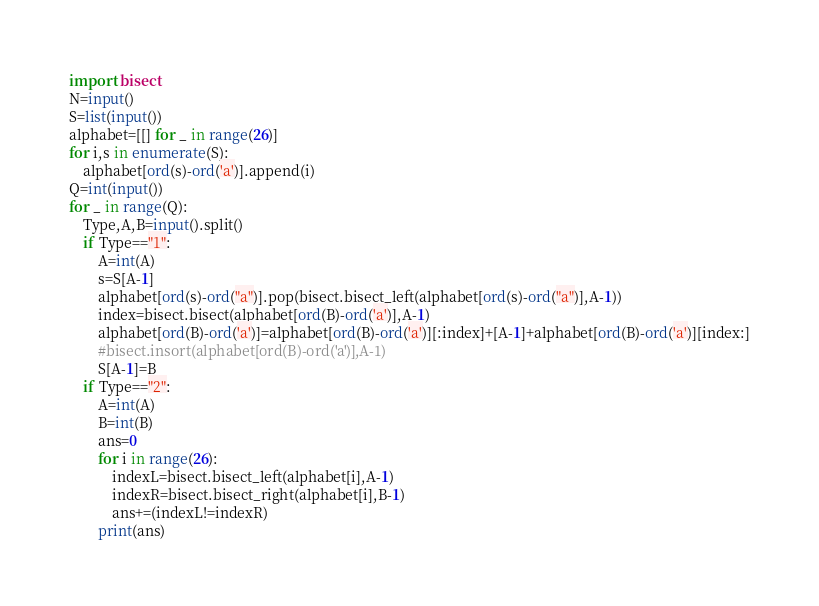Convert code to text. <code><loc_0><loc_0><loc_500><loc_500><_Python_>import bisect
N=input()
S=list(input())
alphabet=[[] for _ in range(26)]
for i,s in enumerate(S):
    alphabet[ord(s)-ord('a')].append(i)
Q=int(input())
for _ in range(Q):
    Type,A,B=input().split()
    if Type=="1":
        A=int(A)
        s=S[A-1]
        alphabet[ord(s)-ord("a")].pop(bisect.bisect_left(alphabet[ord(s)-ord("a")],A-1))
        index=bisect.bisect(alphabet[ord(B)-ord('a')],A-1)
        alphabet[ord(B)-ord('a')]=alphabet[ord(B)-ord('a')][:index]+[A-1]+alphabet[ord(B)-ord('a')][index:]
        #bisect.insort(alphabet[ord(B)-ord('a')],A-1)
        S[A-1]=B
    if Type=="2":
        A=int(A)
        B=int(B)
        ans=0
        for i in range(26):
            indexL=bisect.bisect_left(alphabet[i],A-1)
            indexR=bisect.bisect_right(alphabet[i],B-1)
            ans+=(indexL!=indexR)
        print(ans)
</code> 